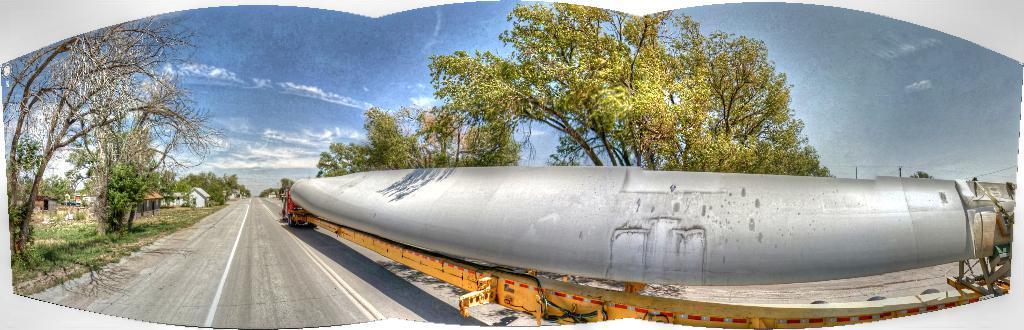Please provide a concise description of this image. In this image I see a vehicle over here and I see the road and I see the trees and in the background I see the houses and I see the sky. 